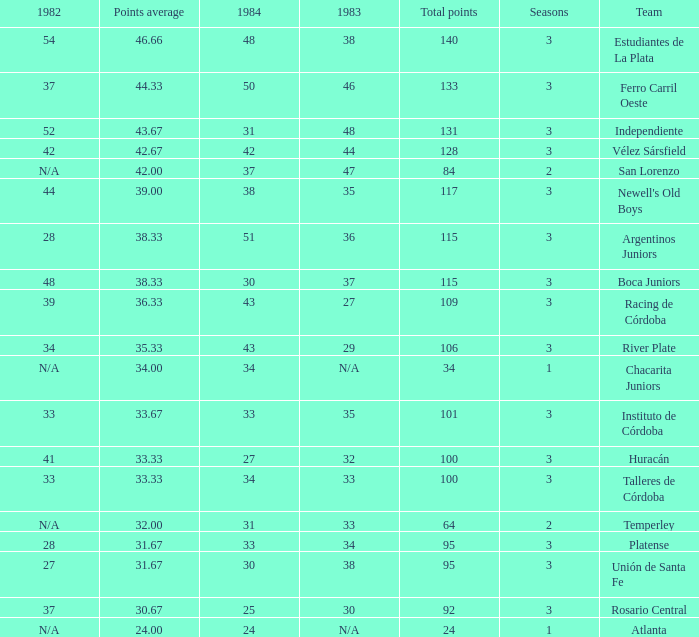What is the points total for the team with points average more than 34, 1984 score more than 37 and N/A in 1982? 0.0. 